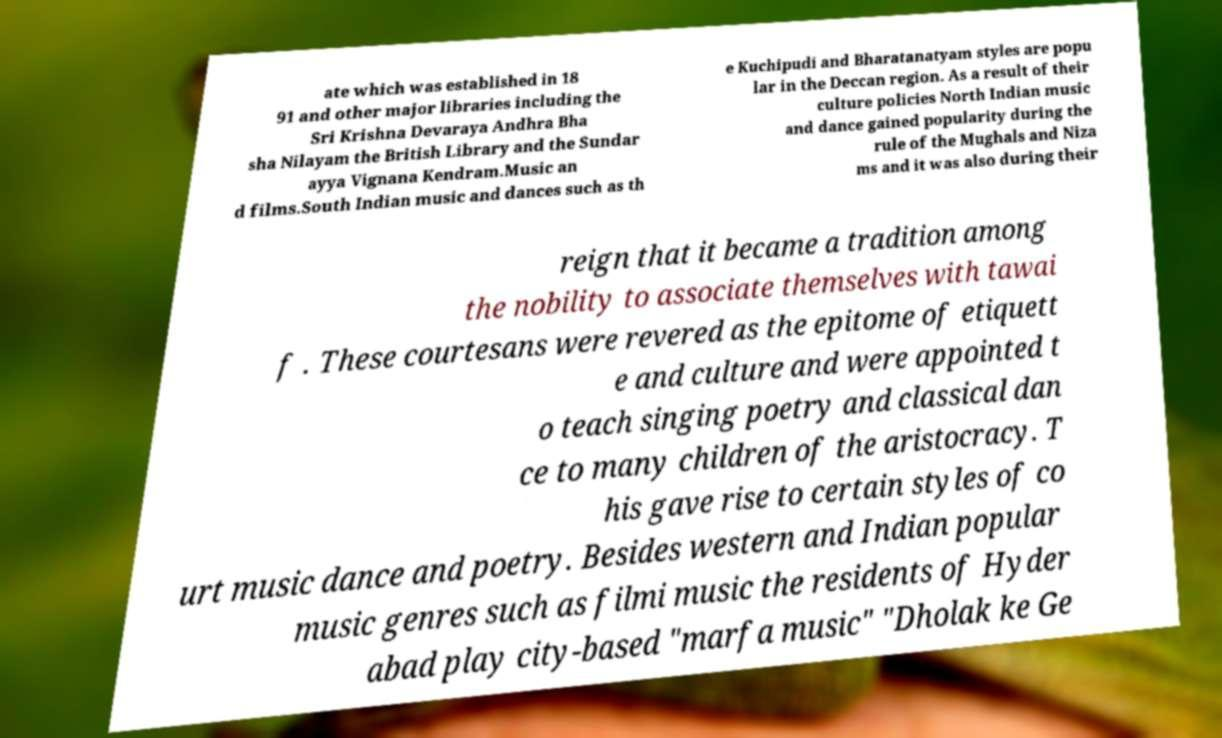There's text embedded in this image that I need extracted. Can you transcribe it verbatim? ate which was established in 18 91 and other major libraries including the Sri Krishna Devaraya Andhra Bha sha Nilayam the British Library and the Sundar ayya Vignana Kendram.Music an d films.South Indian music and dances such as th e Kuchipudi and Bharatanatyam styles are popu lar in the Deccan region. As a result of their culture policies North Indian music and dance gained popularity during the rule of the Mughals and Niza ms and it was also during their reign that it became a tradition among the nobility to associate themselves with tawai f . These courtesans were revered as the epitome of etiquett e and culture and were appointed t o teach singing poetry and classical dan ce to many children of the aristocracy. T his gave rise to certain styles of co urt music dance and poetry. Besides western and Indian popular music genres such as filmi music the residents of Hyder abad play city-based "marfa music" "Dholak ke Ge 